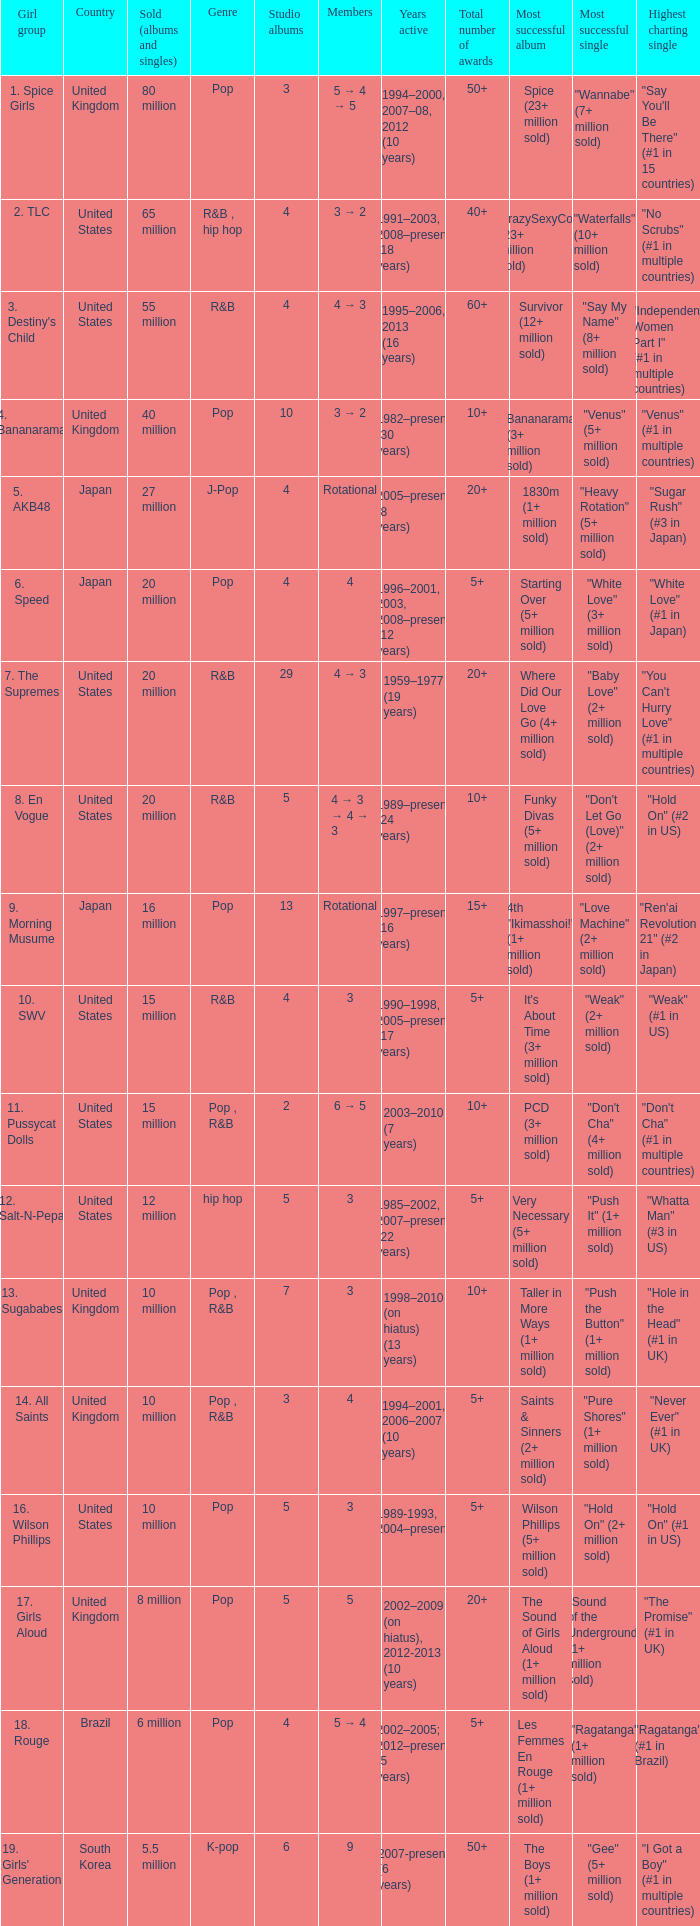How many members were in the group that sold 65 million albums and singles? 3 → 2. Would you be able to parse every entry in this table? {'header': ['Girl group', 'Country', 'Sold (albums and singles)', 'Genre', 'Studio albums', 'Members', 'Years active', 'Total number of awards', 'Most successful album', 'Most successful single', 'Highest charting single'], 'rows': [['1. Spice Girls', 'United Kingdom', '80 million', 'Pop', '3', '5 → 4 → 5', '1994–2000, 2007–08, 2012 (10 years)', '50+', 'Spice (23+ million sold)', '"Wannabe" (7+ million sold)', '"Say You\'ll Be There" (#1 in 15 countries)'], ['2. TLC', 'United States', '65 million', 'R&B , hip hop', '4', '3 → 2', '1991–2003, 2008–present (18 years)', '40+', 'CrazySexyCool (23+ million sold)', '"Waterfalls" (10+ million sold)', '"No Scrubs" (#1 in multiple countries)'], ["3. Destiny's Child", 'United States', '55 million', 'R&B', '4', '4 → 3', '1995–2006, 2013 (16 years)', '60+', 'Survivor (12+ million sold)', '"Say My Name" (8+ million sold)', '"Independent Women Part I" (#1 in multiple countries)'], ['4. Bananarama', 'United Kingdom', '40 million', 'Pop', '10', '3 → 2', '1982–present (30 years)', '10+', 'Bananarama (3+ million sold)', '"Venus" (5+ million sold)', '"Venus" (#1 in multiple countries)'], ['5. AKB48', 'Japan', '27 million', 'J-Pop', '4', 'Rotational', '2005–present (8 years)', '20+', '1830m (1+ million sold)', '"Heavy Rotation" (5+ million sold)', '"Sugar Rush" (#3 in Japan)'], ['6. Speed', 'Japan', '20 million', 'Pop', '4', '4', '1996–2001, 2003, 2008–present (12 years)', '5+', 'Starting Over (5+ million sold)', '"White Love" (3+ million sold)', '"White Love" (#1 in Japan)'], ['7. The Supremes', 'United States', '20 million', 'R&B', '29', '4 → 3', '1959–1977 (19 years)', '20+', 'Where Did Our Love Go (4+ million sold)', '"Baby Love" (2+ million sold)', '"You Can\'t Hurry Love" (#1 in multiple countries)'], ['8. En Vogue', 'United States', '20 million', 'R&B', '5', '4 → 3 → 4 → 3', '1989–present (24 years)', '10+', 'Funky Divas (5+ million sold)', '"Don\'t Let Go (Love)" (2+ million sold)', '"Hold On" (#2 in US)'], ['9. Morning Musume', 'Japan', '16 million', 'Pop', '13', 'Rotational', '1997–present (16 years)', '15+', '4th "Ikimasshoi!" (1+ million sold)', '"Love Machine" (2+ million sold)', '"Ren\'ai Revolution 21" (#2 in Japan)'], ['10. SWV', 'United States', '15 million', 'R&B', '4', '3', '1990–1998, 2005–present (17 years)', '5+', "It's About Time (3+ million sold)", '"Weak" (2+ million sold)', '"Weak" (#1 in US)'], ['11. Pussycat Dolls', 'United States', '15 million', 'Pop , R&B', '2', '6 → 5', '2003–2010 (7 years)', '10+', 'PCD (3+ million sold)', '"Don\'t Cha" (4+ million sold)', '"Don\'t Cha" (#1 in multiple countries)'], ['12. Salt-N-Pepa', 'United States', '12 million', 'hip hop', '5', '3', '1985–2002, 2007–present (22 years)', '5+', 'Very Necessary (5+ million sold)', '"Push It" (1+ million sold)', '"Whatta Man" (#3 in US)'], ['13. Sugababes', 'United Kingdom', '10 million', 'Pop , R&B', '7', '3', '1998–2010 (on hiatus) (13 years)', '10+', 'Taller in More Ways (1+ million sold)', '"Push the Button" (1+ million sold)', '"Hole in the Head" (#1 in UK)'], ['14. All Saints', 'United Kingdom', '10 million', 'Pop , R&B', '3', '4', '1994–2001, 2006–2007 (10 years)', '5+', 'Saints & Sinners (2+ million sold)', '"Pure Shores" (1+ million sold)', '"Never Ever" (#1 in UK)'], ['16. Wilson Phillips', 'United States', '10 million', 'Pop', '5', '3', '1989-1993, 2004–present', '5+', 'Wilson Phillips (5+ million sold)', '"Hold On" (2+ million sold)', '"Hold On" (#1 in US)'], ['17. Girls Aloud', 'United Kingdom', '8 million', 'Pop', '5', '5', '2002–2009 (on hiatus), 2012-2013 (10 years)', '20+', 'The Sound of Girls Aloud (1+ million sold)', '"Sound of the Underground" (1+ million sold)', '"The Promise" (#1 in UK)'], ['18. Rouge', 'Brazil', '6 million', 'Pop', '4', '5 → 4', '2002–2005; 2012–present (5 years)', '5+', 'Les Femmes En Rouge (1+ million sold)', '"Ragatanga" (1+ million sold)', '"Ragatanga" (#1 in Brazil)'], ["19. Girls' Generation", 'South Korea', '5.5 million', 'K-pop', '6', '9', '2007-present (6 years)', '50+', 'The Boys (1+ million sold)', '"Gee" (5+ million sold)', '"I Got a Boy" (#1 in multiple countries)']]} 